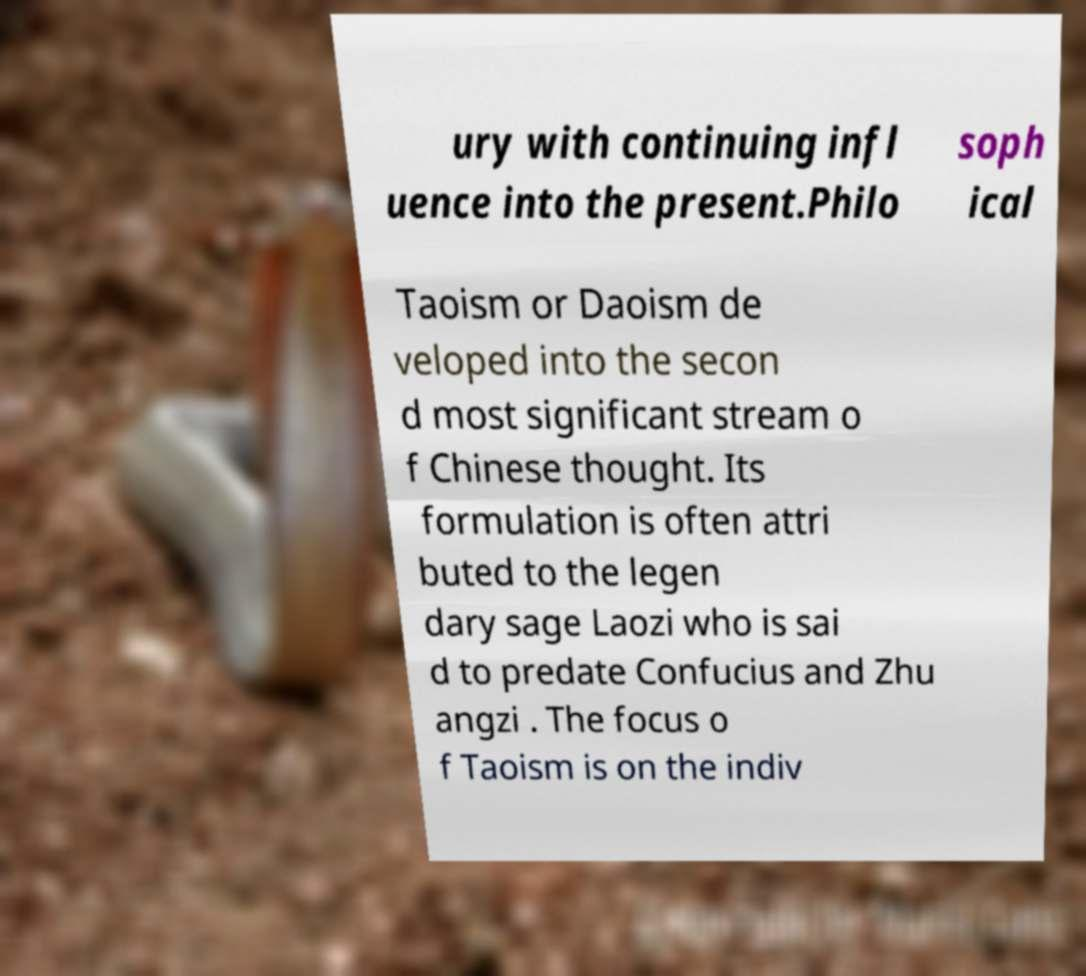For documentation purposes, I need the text within this image transcribed. Could you provide that? ury with continuing infl uence into the present.Philo soph ical Taoism or Daoism de veloped into the secon d most significant stream o f Chinese thought. Its formulation is often attri buted to the legen dary sage Laozi who is sai d to predate Confucius and Zhu angzi . The focus o f Taoism is on the indiv 